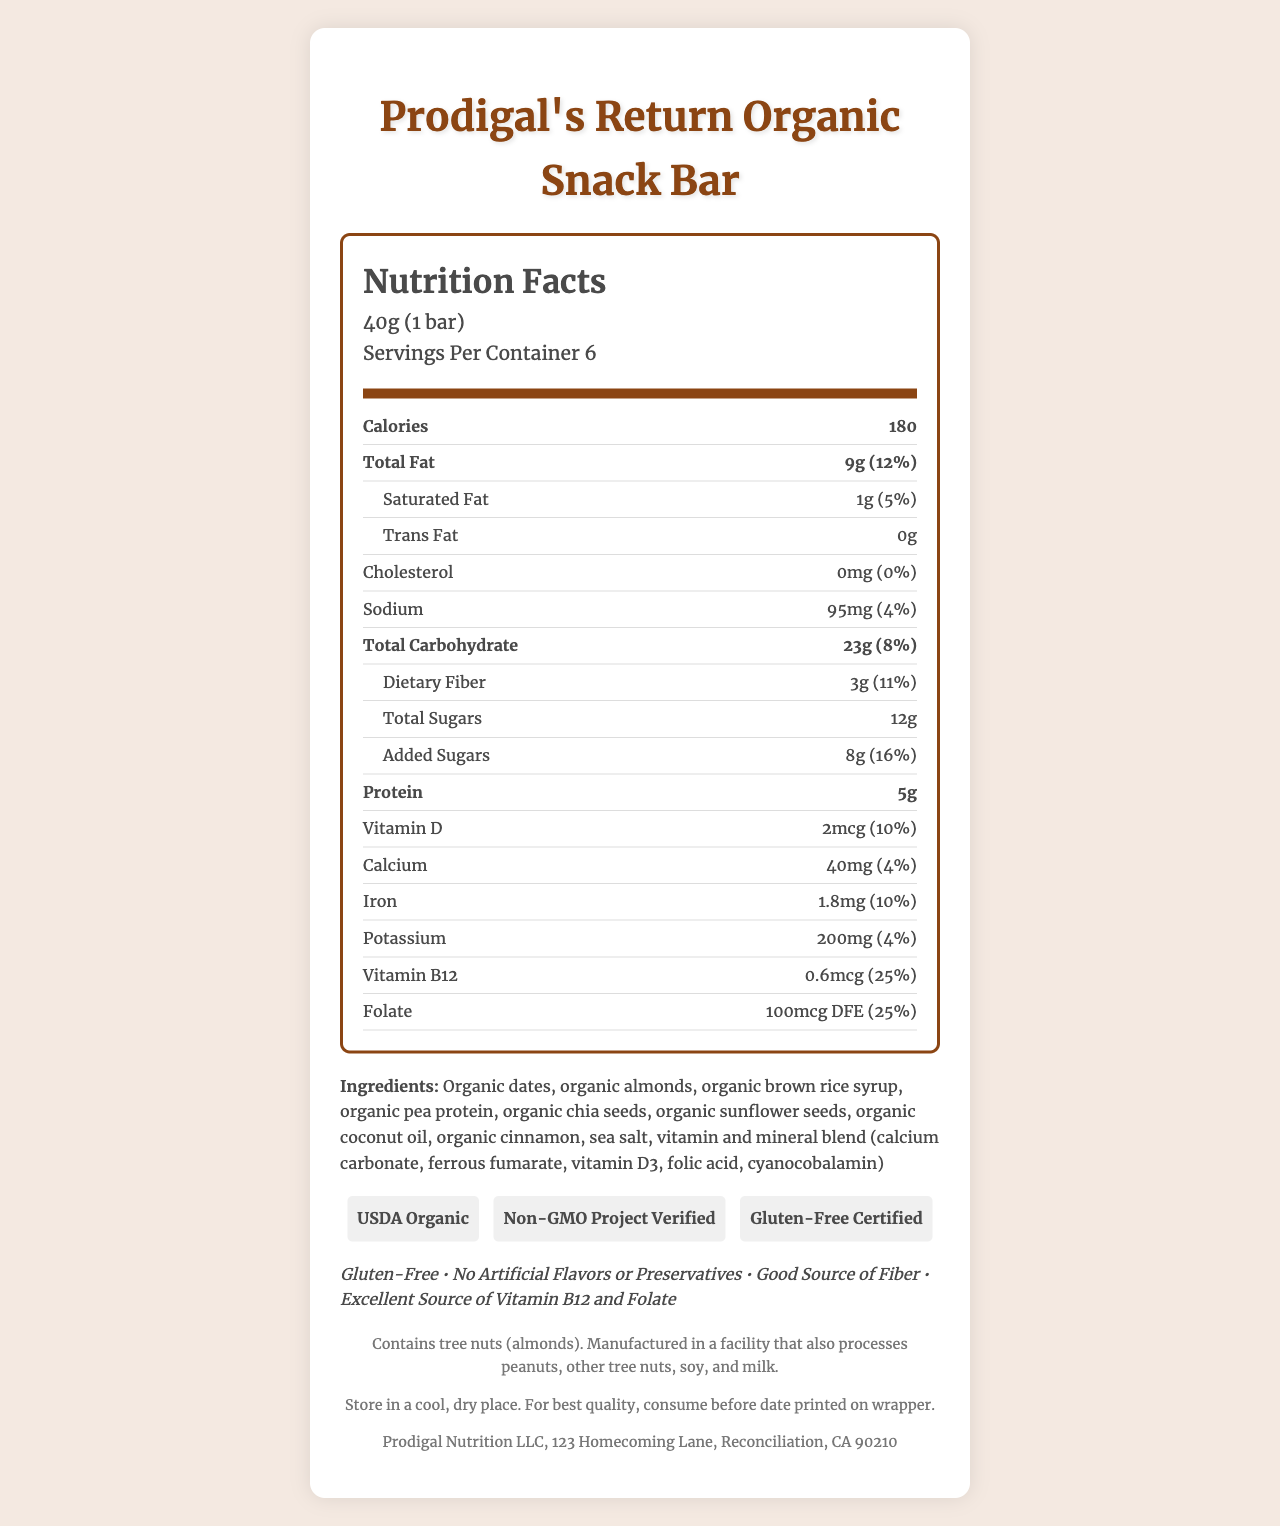What is the serving size of the Prodigal's Return Organic Snack Bar? The serving size is stated directly under the product name and nutrition title.
Answer: 40g (1 bar) How many servings are there in a container? The number of servings per container is listed under the serving size information.
Answer: 6 What are the total calories per serving? The calories per serving are highlighted prominently in the nutrition facts list.
Answer: 180 What amount of total fat does one serving contain? The total fat amount is listed under the calories information.
Answer: 9g How much dietary fiber is in one serving? The amount of dietary fiber is specified under the total carbohydrate section.
Answer: 3g Which vitamin has a daily value percentage of 25%? A. Vitamin D B. Vitamin B12 C. Vitamin C The daily value percentage of Vitamin B12 is shown as 25% in the nutrition facts.
Answer: B. Vitamin B12 How much calcium is in one serving of the snack bar? A. 20mg B. 30mg C. 40mg The calcium amount for one serving is listed as 40mg in the nutrition facts table.
Answer: C. 40mg Does the snack bar contain any tree nuts? The allergen information states that it contains tree nuts (almonds).
Answer: Yes Is the Prodigal's Return Organic Snack Bar gluten-free? The certification sections list "Gluten-Free Certified," and the marketing claims list "Gluten-Free."
Answer: Yes Summarize the main nutritional benefits of the Prodigal's Return Organic Snack Bar. The document emphasizes the snack bar's nutritional content, allergen information, certifications, and marketing claims to highlight its health benefits.
Answer: The Prodigal's Return Organic Snack Bar is a gluten-free, organic snack containing 180 calories per serving. It has significant amounts of protein (5g), dietary fiber (3g), and added vitamins and minerals like vitamin B12 (25% DV) and folate (25% DV). The snack bar is also characterized by its lack of artificial flavors or preservatives. What marketing claims are made about artificial flavors or preservatives? This claim is explicitly listed in the marketing claims section.
Answer: No Artificial Flavors or Preservatives Is the vitamin and mineral blend in the snack bar described in detail? The ingredients list details the components of the vitamin and mineral blend, including calcium carbonate, ferrous fumarate, vitamin D3, folic acid, and cyanocobalamin.
Answer: Yes Where is Prodigal Nutrition LLC located? The company information at the bottom of the document includes the address.
Answer: 123 Homecoming Lane, Reconciliation, CA 90210 When should the Prodigal's Return Organic Snack Bar be consumed for best quality? The storage instructions specify to consume the snack bar before the date printed on the wrapper for best quality.
Answer: Before the date printed on the wrapper Can you determine the fiber source for the snack bar from the document? The document lists "organic chia seeds" and "organic sunflower seeds" as ingredients, which might contribute to dietary fiber, but it doesn't explicitly state the fiber source.
Answer: Cannot be determined 